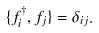<formula> <loc_0><loc_0><loc_500><loc_500>\{ f _ { i } ^ { \dagger } , f _ { j } \} = \delta _ { i j } .</formula> 